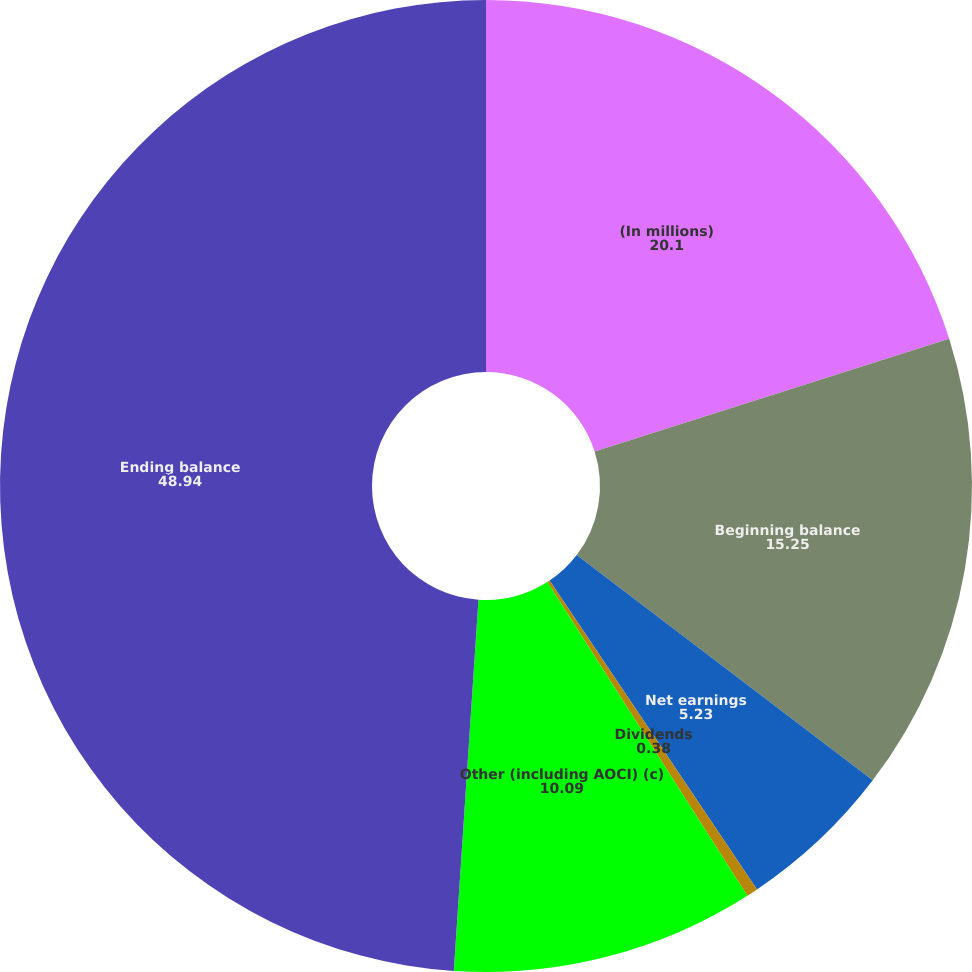Convert chart to OTSL. <chart><loc_0><loc_0><loc_500><loc_500><pie_chart><fcel>(In millions)<fcel>Beginning balance<fcel>Net earnings<fcel>Dividends<fcel>Other (including AOCI) (c)<fcel>Ending balance<nl><fcel>20.1%<fcel>15.25%<fcel>5.23%<fcel>0.38%<fcel>10.09%<fcel>48.94%<nl></chart> 